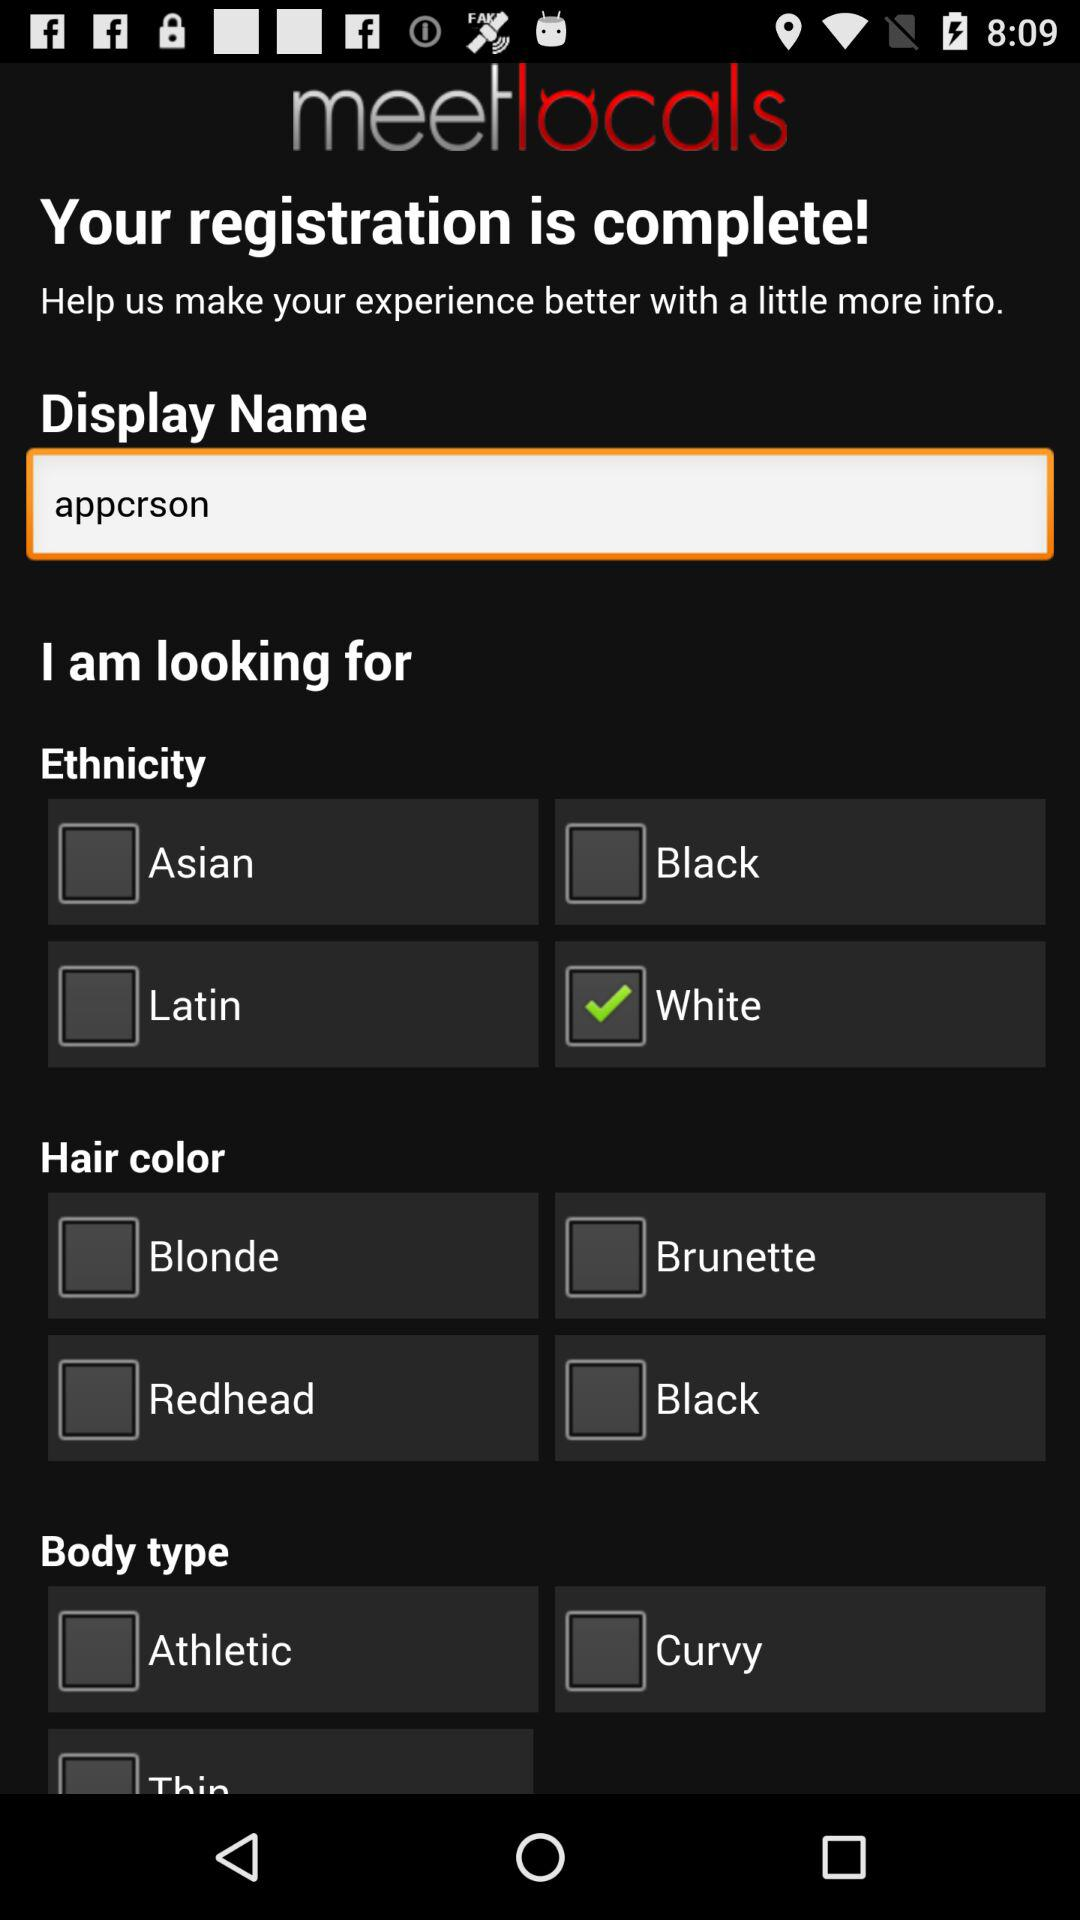What is the display name? The display name is "appcrson". 